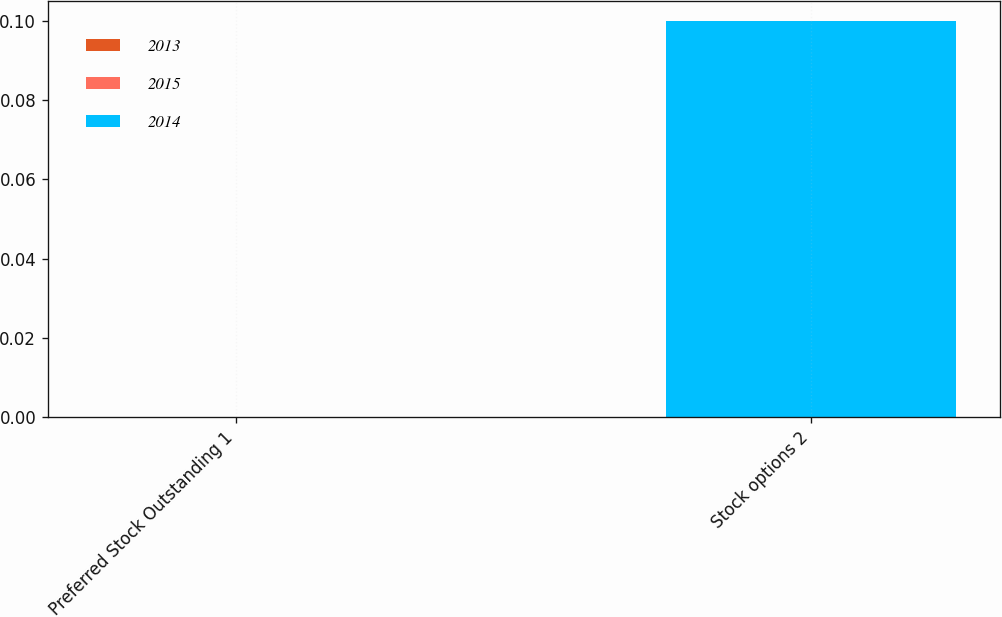Convert chart. <chart><loc_0><loc_0><loc_500><loc_500><stacked_bar_chart><ecel><fcel>Preferred Stock Outstanding 1<fcel>Stock options 2<nl><fcel>2013<fcel>0<fcel>0<nl><fcel>2015<fcel>0<fcel>0<nl><fcel>2014<fcel>0<fcel>0.1<nl></chart> 